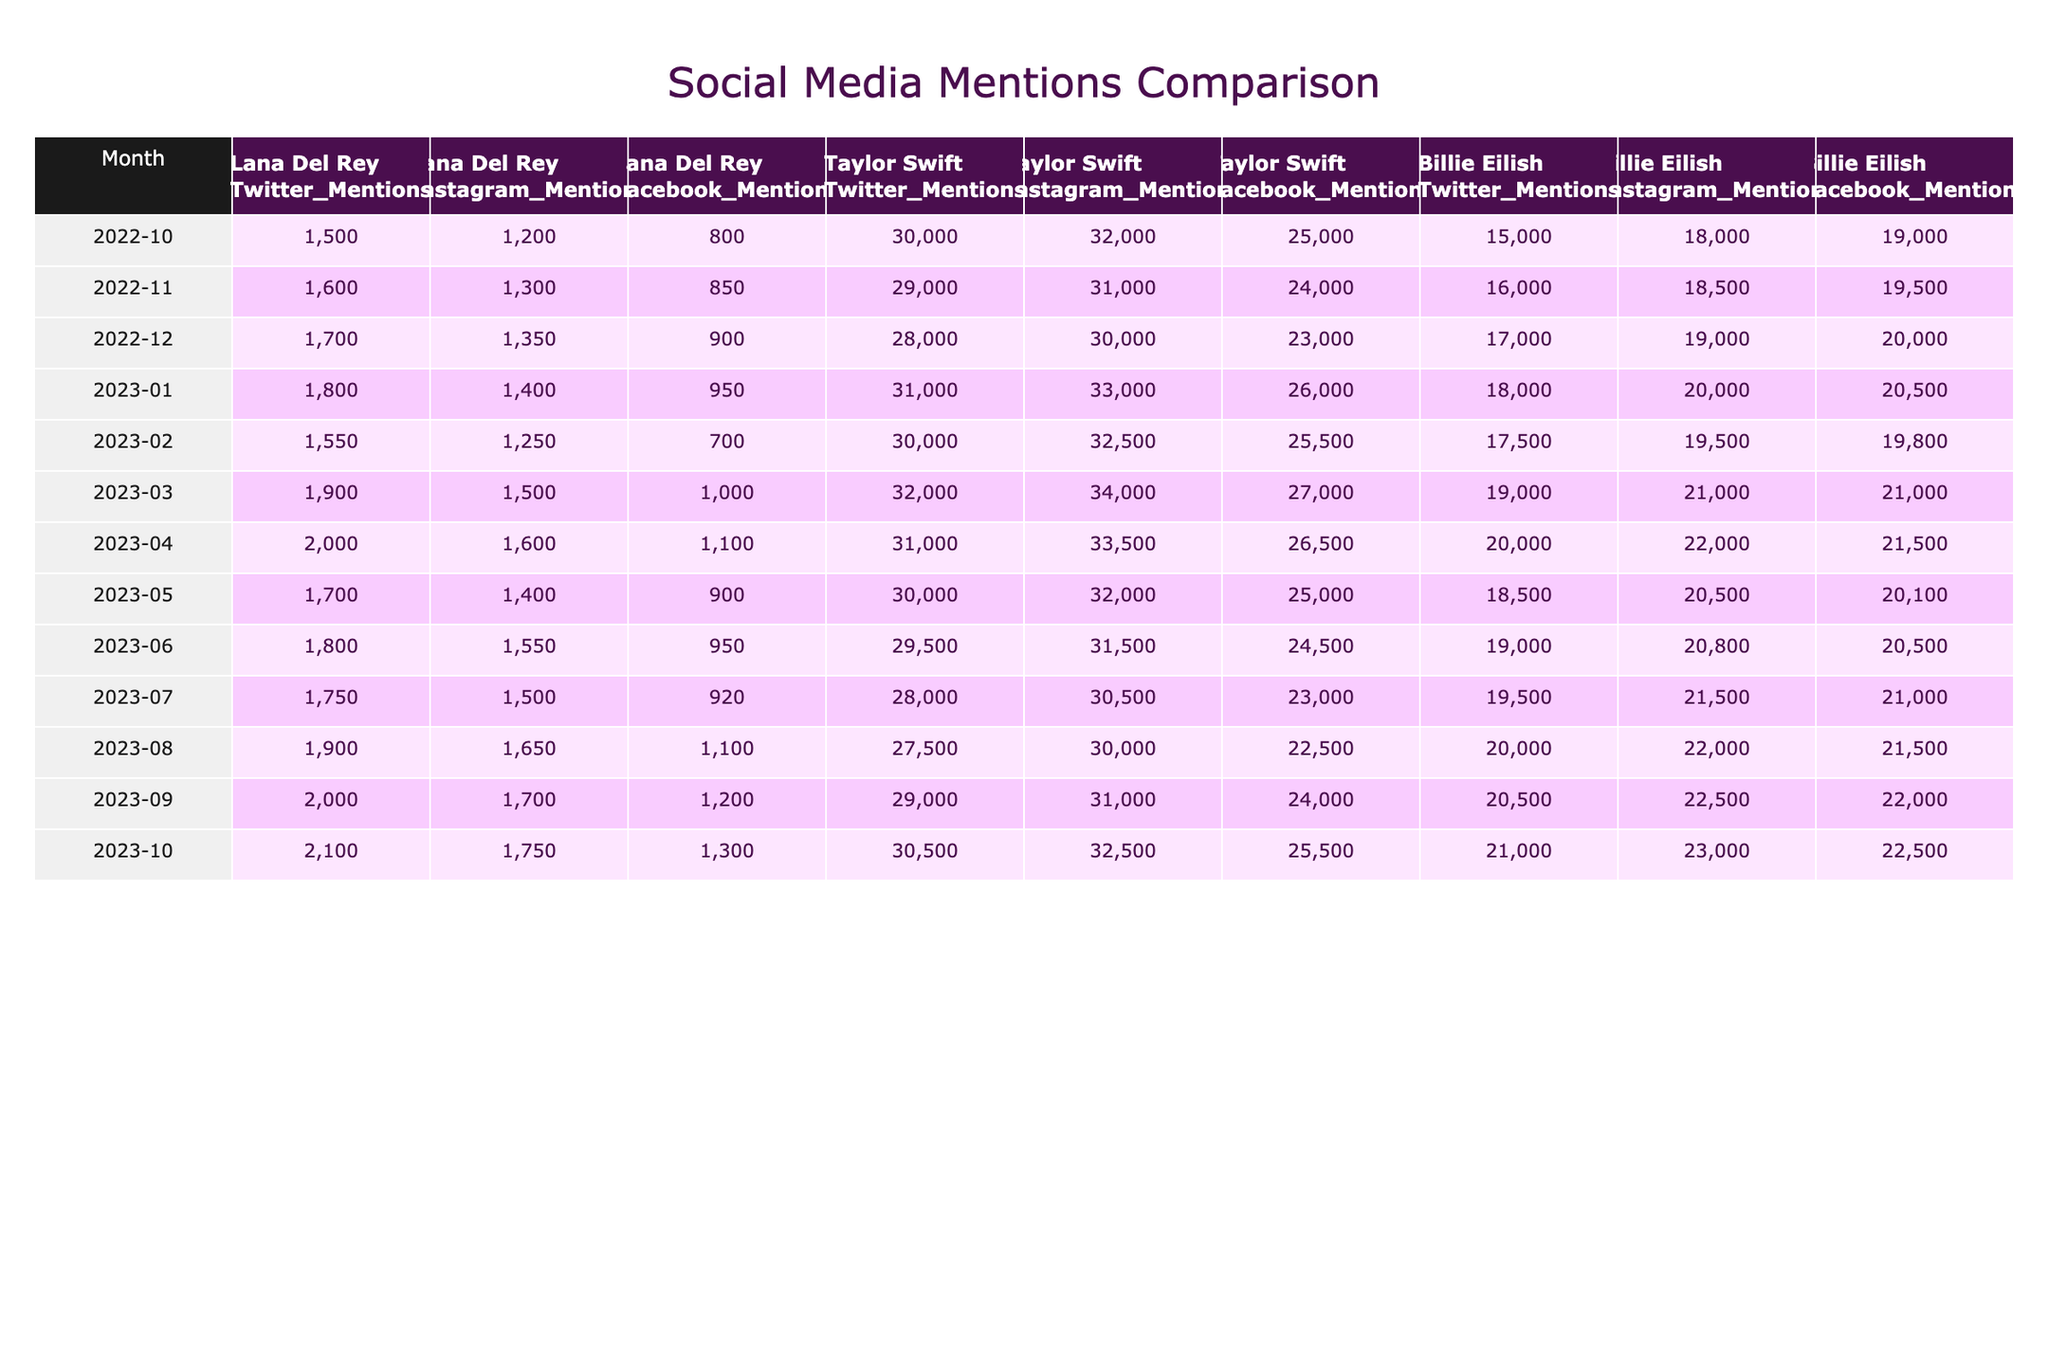What was the highest number of Twitter mentions Lana Del Rey received in a single month? By inspecting the Twitter mentions for Lana Del Rey from October 2022 to October 2023, we see the highest value is 2100 mentions in October 2023.
Answer: 2100 In which month did Lana Del Rey have the lowest number of Facebook mentions? Looking at the Facebook mentions for Lana Del Rey, the lowest value is 700 mentions in February 2023.
Answer: February 2023 How many total Twitter mentions did Taylor Swift receive from October 2022 to October 2023? To find the total Twitter mentions for Taylor Swift, we sum the monthly values: 30000 + 29000 + 28000 + 31000 + 30000 + 32000 + 31000 + 30000 + 29500 + 28000 + 27500 + 29000 + 30500 = 373500.
Answer: 373500 What is the average number of Instagram mentions for Billie Eilish over the past year? To calculate the average Instagram mentions for Billie Eilish, first find the sum of the monthly values: 18000 + 18500 + 19000 + 20000 + 19500 + 21000 + 22000 + 20500 + 20800 + 21500 + 22000 + 23000 = 246800. Divide by 12 (the number of months): 246800/12 = 20566.67.
Answer: 20567 Did Lana Del Rey ever exceed 2000 mentions in Facebook over the last year? By checking the Facebook mentions data for Lana Del Rey, we find that the highest value is 1300 mentions in October 2023, which is below 2000.
Answer: No Which artist had consistently higher Twitter mentions than Lana Del Rey during this period? Comparing the monthly data for Twitter mentions, Taylor Swift's values are always higher than those of Lana Del Rey. For every month, Taylor Swift's mentions outweigh Lana Del Rey's.
Answer: Taylor Swift What is the difference in Facebook mentions between Lana Del Rey and Billie Eilish in March 2023? For March 2023, Lana Del Rey had 1000 Facebook mentions and Billie Eilish had 21000. The difference is 21000 - 1000 = 20000 mentions.
Answer: 20000 